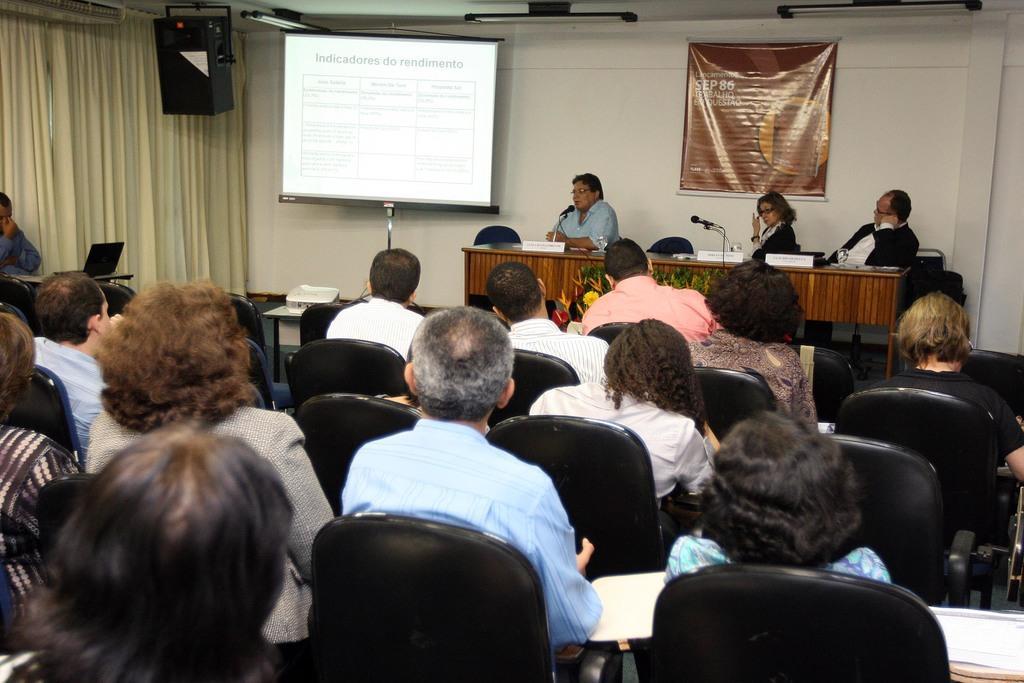Please provide a concise description of this image. In this image we can see a group of people sitting on chairs. In the center of the image we can see a screen with stand, projector placed on the surface. In the right side of the image we can see some microphones, glasses and some boards placed on the table and we can see some flowers. On the left side of the image we can see a laptop. In the background, we can see a speaker, some lights and a banner with some text. 